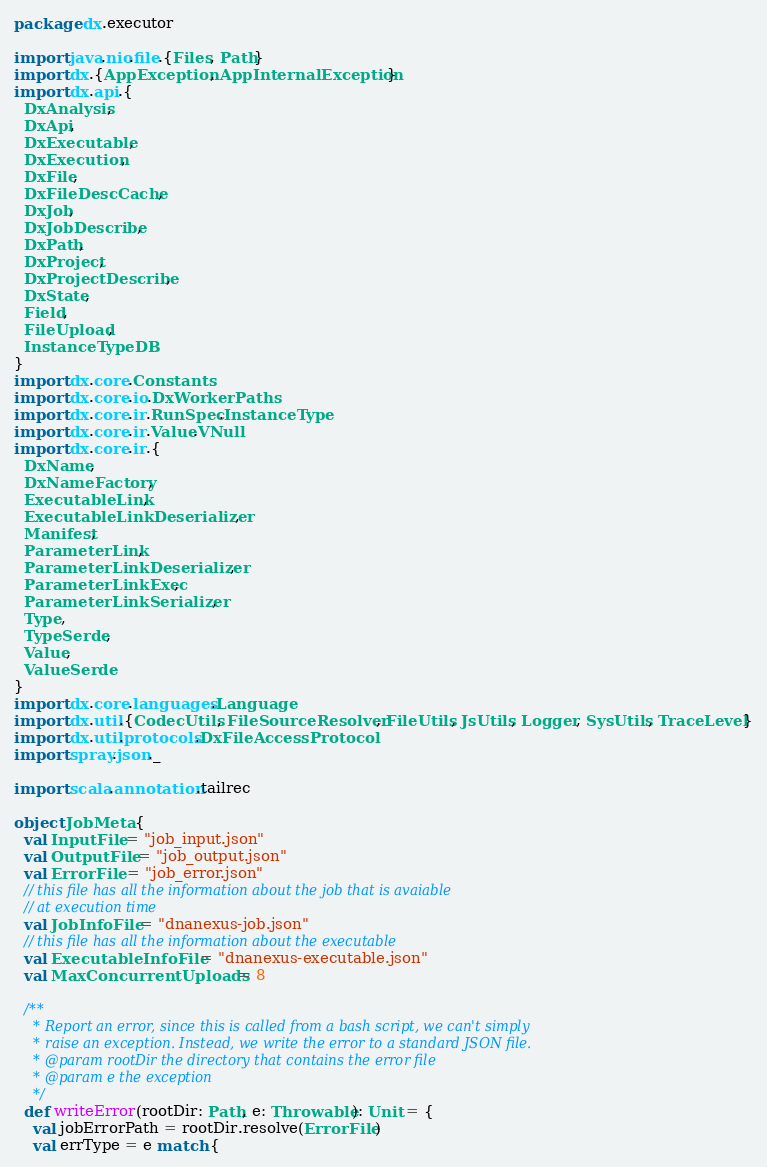<code> <loc_0><loc_0><loc_500><loc_500><_Scala_>package dx.executor

import java.nio.file.{Files, Path}
import dx.{AppException, AppInternalException}
import dx.api.{
  DxAnalysis,
  DxApi,
  DxExecutable,
  DxExecution,
  DxFile,
  DxFileDescCache,
  DxJob,
  DxJobDescribe,
  DxPath,
  DxProject,
  DxProjectDescribe,
  DxState,
  Field,
  FileUpload,
  InstanceTypeDB
}
import dx.core.Constants
import dx.core.io.DxWorkerPaths
import dx.core.ir.RunSpec.InstanceType
import dx.core.ir.Value.VNull
import dx.core.ir.{
  DxName,
  DxNameFactory,
  ExecutableLink,
  ExecutableLinkDeserializer,
  Manifest,
  ParameterLink,
  ParameterLinkDeserializer,
  ParameterLinkExec,
  ParameterLinkSerializer,
  Type,
  TypeSerde,
  Value,
  ValueSerde
}
import dx.core.languages.Language
import dx.util.{CodecUtils, FileSourceResolver, FileUtils, JsUtils, Logger, SysUtils, TraceLevel}
import dx.util.protocols.DxFileAccessProtocol
import spray.json._

import scala.annotation.tailrec

object JobMeta {
  val InputFile = "job_input.json"
  val OutputFile = "job_output.json"
  val ErrorFile = "job_error.json"
  // this file has all the information about the job that is avaiable
  // at execution time
  val JobInfoFile = "dnanexus-job.json"
  // this file has all the information about the executable
  val ExecutableInfoFile = "dnanexus-executable.json"
  val MaxConcurrentUploads = 8

  /**
    * Report an error, since this is called from a bash script, we can't simply
    * raise an exception. Instead, we write the error to a standard JSON file.
    * @param rootDir the directory that contains the error file
    * @param e the exception
    */
  def writeError(rootDir: Path, e: Throwable): Unit = {
    val jobErrorPath = rootDir.resolve(ErrorFile)
    val errType = e match {</code> 